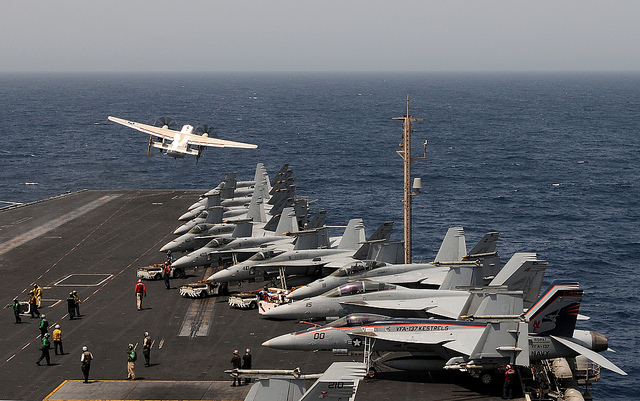<image>Are the parked planes F-18's? I don't know if the parked planes are F-18's. Are the parked planes F-18's? I don't know if the parked planes are F-18's. 